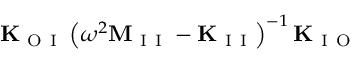<formula> <loc_0><loc_0><loc_500><loc_500>K _ { O I } \left ( \omega ^ { 2 } M _ { I I } - K _ { I I } \right ) ^ { - 1 } K _ { I O }</formula> 